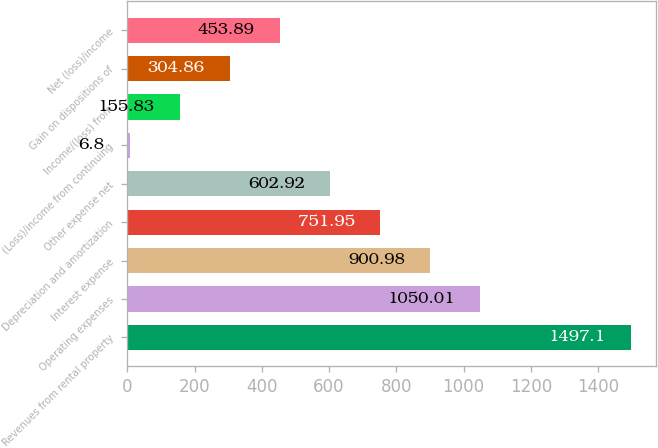Convert chart. <chart><loc_0><loc_0><loc_500><loc_500><bar_chart><fcel>Revenues from rental property<fcel>Operating expenses<fcel>Interest expense<fcel>Depreciation and amortization<fcel>Other expense net<fcel>(Loss)/income from continuing<fcel>Income/(loss) from<fcel>Gain on dispositions of<fcel>Net (loss)/income<nl><fcel>1497.1<fcel>1050.01<fcel>900.98<fcel>751.95<fcel>602.92<fcel>6.8<fcel>155.83<fcel>304.86<fcel>453.89<nl></chart> 